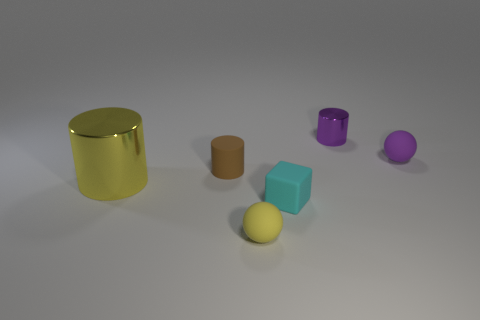Subtract all small cylinders. How many cylinders are left? 1 Add 3 rubber objects. How many objects exist? 9 Subtract all balls. How many objects are left? 4 Subtract all purple spheres. Subtract all green blocks. How many spheres are left? 1 Subtract all big cylinders. Subtract all tiny cyan matte balls. How many objects are left? 5 Add 6 yellow matte balls. How many yellow matte balls are left? 7 Add 4 matte spheres. How many matte spheres exist? 6 Subtract 0 gray spheres. How many objects are left? 6 